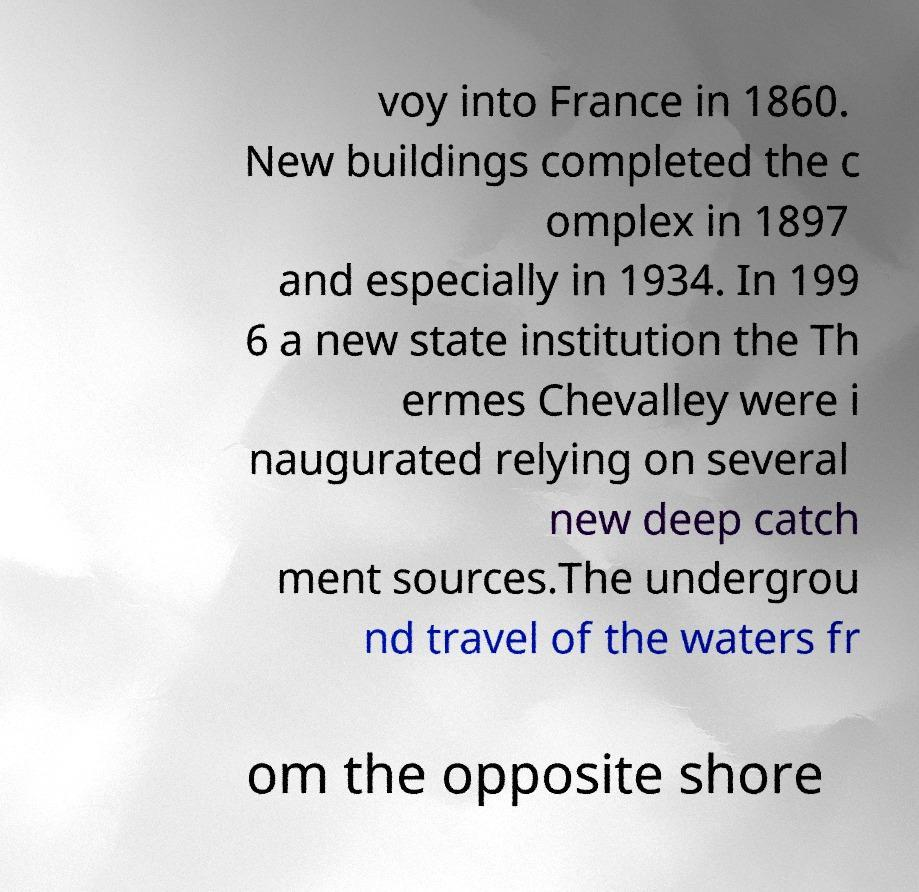Please read and relay the text visible in this image. What does it say? voy into France in 1860. New buildings completed the c omplex in 1897 and especially in 1934. In 199 6 a new state institution the Th ermes Chevalley were i naugurated relying on several new deep catch ment sources.The undergrou nd travel of the waters fr om the opposite shore 